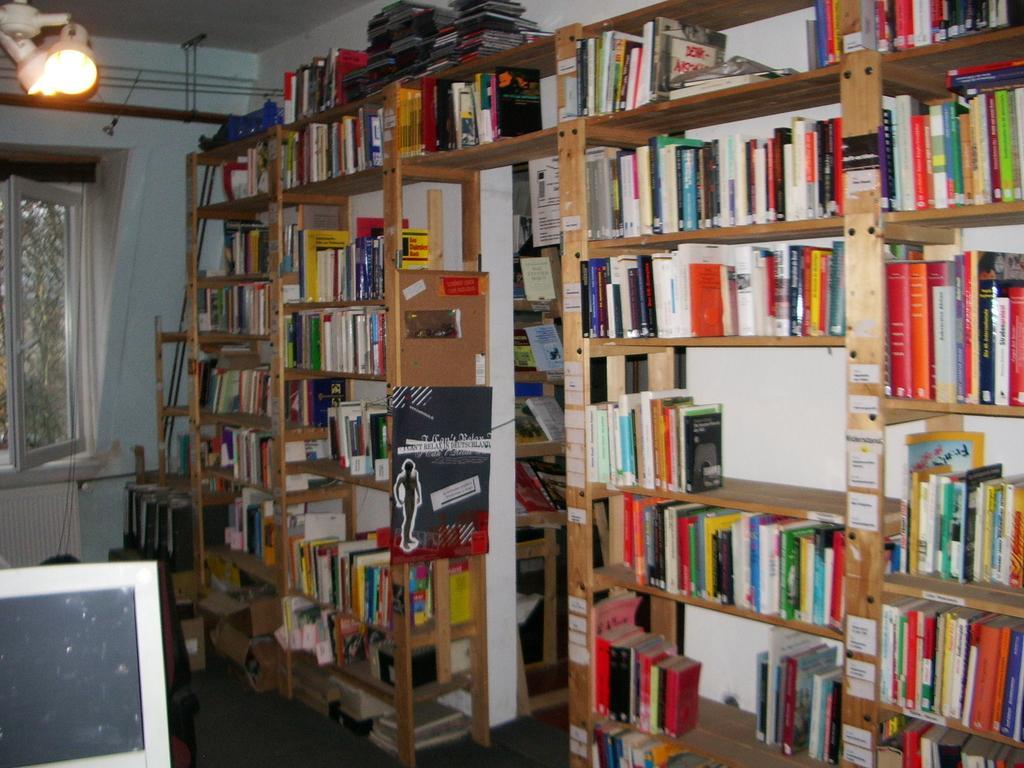Please provide a concise description of this image. In this picture I can see books in the racks, there is a monitor, light, and in the background there is a window. 